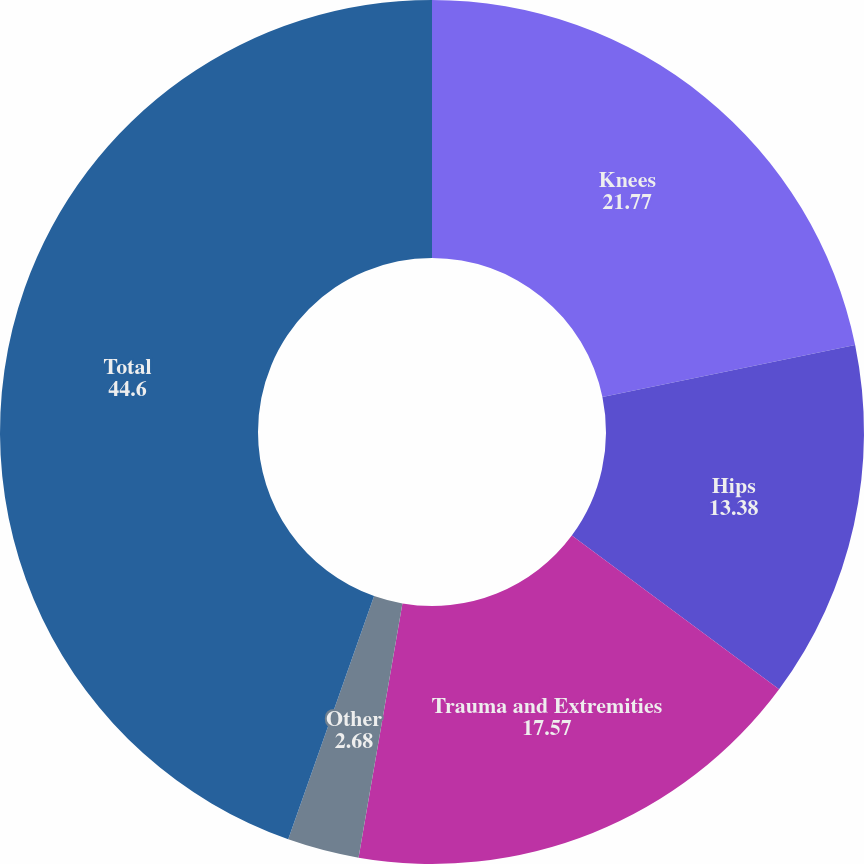<chart> <loc_0><loc_0><loc_500><loc_500><pie_chart><fcel>Knees<fcel>Hips<fcel>Trauma and Extremities<fcel>Other<fcel>Total<nl><fcel>21.77%<fcel>13.38%<fcel>17.57%<fcel>2.68%<fcel>44.6%<nl></chart> 